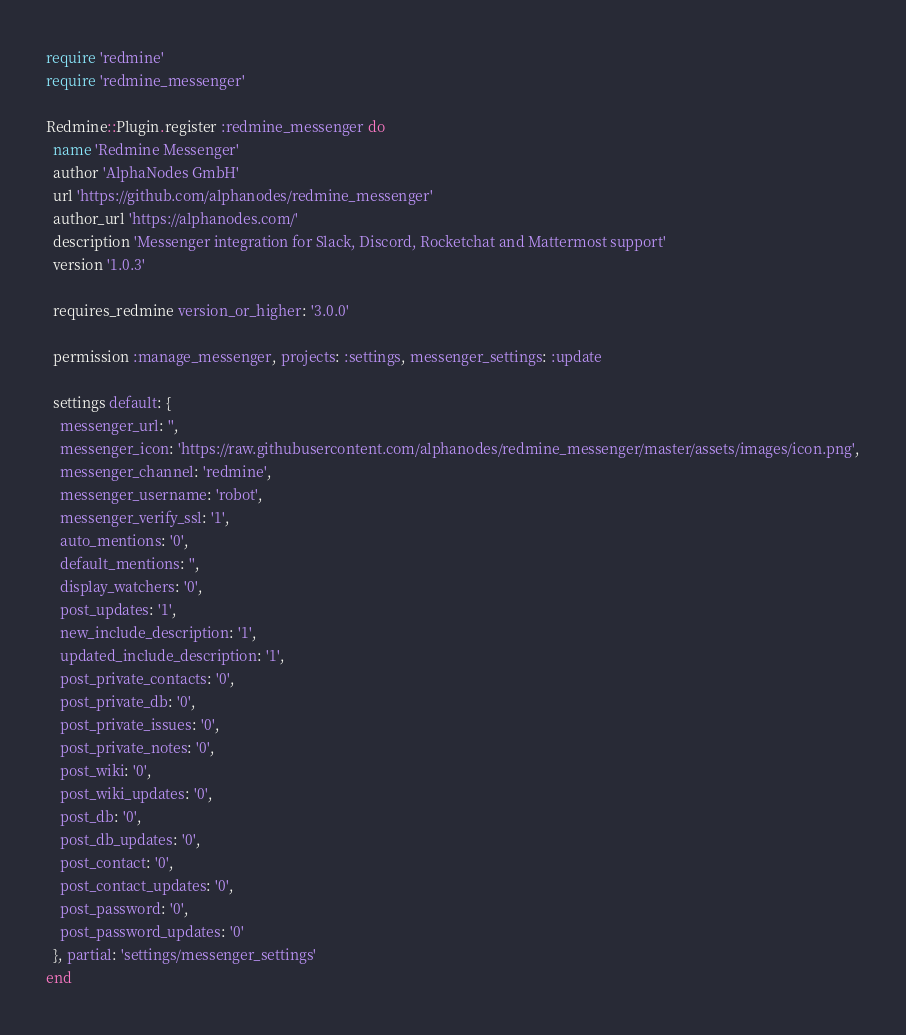<code> <loc_0><loc_0><loc_500><loc_500><_Ruby_>require 'redmine'
require 'redmine_messenger'

Redmine::Plugin.register :redmine_messenger do
  name 'Redmine Messenger'
  author 'AlphaNodes GmbH'
  url 'https://github.com/alphanodes/redmine_messenger'
  author_url 'https://alphanodes.com/'
  description 'Messenger integration for Slack, Discord, Rocketchat and Mattermost support'
  version '1.0.3'

  requires_redmine version_or_higher: '3.0.0'

  permission :manage_messenger, projects: :settings, messenger_settings: :update

  settings default: {
    messenger_url: '',
    messenger_icon: 'https://raw.githubusercontent.com/alphanodes/redmine_messenger/master/assets/images/icon.png',
    messenger_channel: 'redmine',
    messenger_username: 'robot',
    messenger_verify_ssl: '1',
    auto_mentions: '0',
    default_mentions: '',
    display_watchers: '0',
    post_updates: '1',
    new_include_description: '1',
    updated_include_description: '1',
    post_private_contacts: '0',
    post_private_db: '0',
    post_private_issues: '0',
    post_private_notes: '0',
    post_wiki: '0',
    post_wiki_updates: '0',
    post_db: '0',
    post_db_updates: '0',
    post_contact: '0',
    post_contact_updates: '0',
    post_password: '0',
    post_password_updates: '0'
  }, partial: 'settings/messenger_settings'
end
</code> 